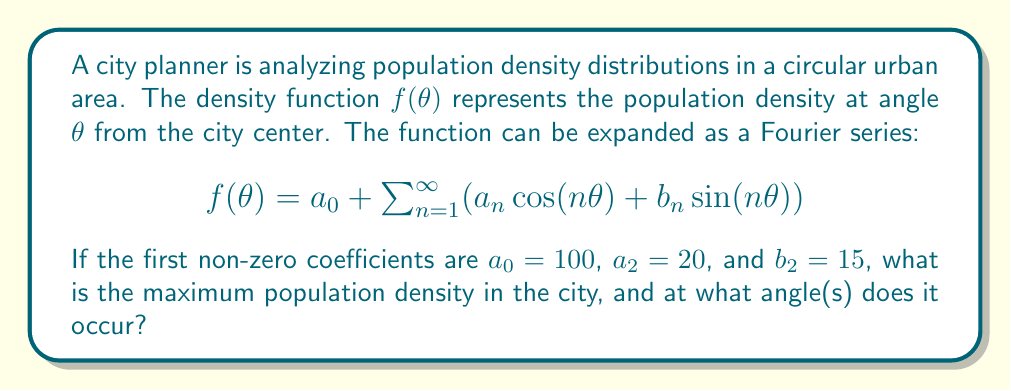Give your solution to this math problem. To solve this problem, we'll follow these steps:

1) The given function simplifies to:
   $$f(\theta) = 100 + 20\cos(2\theta) + 15\sin(2\theta)$$

2) This can be rewritten as:
   $$f(\theta) = 100 + \sqrt{20^2 + 15^2} \cos(2\theta - \phi)$$
   where $\phi = \arctan(\frac{15}{20})$

3) Calculate $\sqrt{20^2 + 15^2}$:
   $$\sqrt{20^2 + 15^2} = \sqrt{400 + 225} = \sqrt{625} = 25$$

4) Calculate $\phi$:
   $$\phi = \arctan(\frac{15}{20}) \approx 0.6435 \text{ radians}$$

5) Now we have:
   $$f(\theta) = 100 + 25\cos(2\theta - 0.6435)$$

6) The maximum value will occur when $\cos(2\theta - 0.6435) = 1$, i.e., when $2\theta - 0.6435 = 0$

7) Solve for $\theta$:
   $$\theta = \frac{0.6435}{2} \approx 0.3218 \text{ radians} \approx 18.44°$$

8) The maximum value is:
   $$f_{max} = 100 + 25 = 125$$

9) Due to the periodicity of cosine, this maximum also occurs at $\theta + \pi \approx 3.4636 \text{ radians} \approx 198.44°$
Answer: Maximum density: 125; Angles: 18.44° and 198.44° 